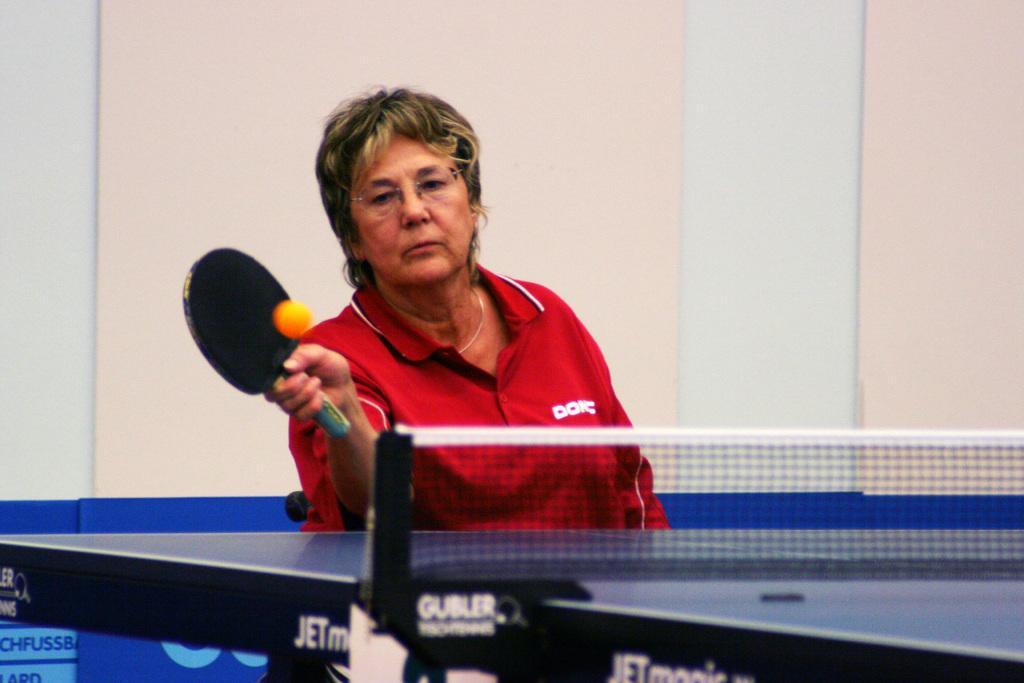In one or two sentences, can you explain what this image depicts? A woman is playing table tennis wearing a red t shirt. 